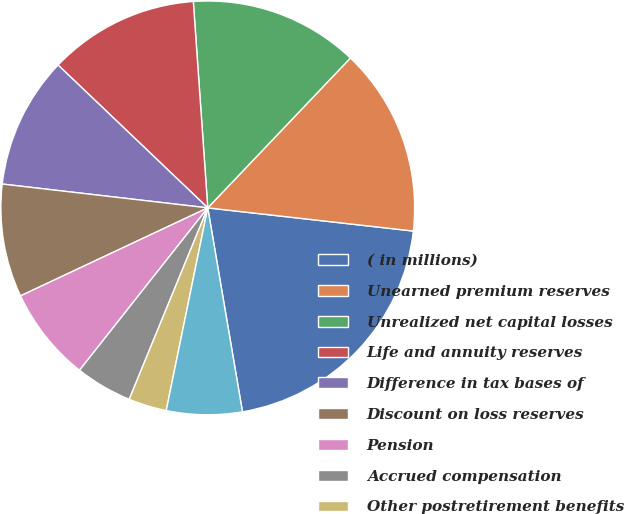Convert chart. <chart><loc_0><loc_0><loc_500><loc_500><pie_chart><fcel>( in millions)<fcel>Unearned premium reserves<fcel>Unrealized net capital losses<fcel>Life and annuity reserves<fcel>Difference in tax bases of<fcel>Discount on loss reserves<fcel>Pension<fcel>Accrued compensation<fcel>Other postretirement benefits<fcel>Other assets<nl><fcel>20.53%<fcel>14.68%<fcel>13.22%<fcel>11.76%<fcel>10.29%<fcel>8.83%<fcel>7.37%<fcel>4.44%<fcel>2.98%<fcel>5.9%<nl></chart> 